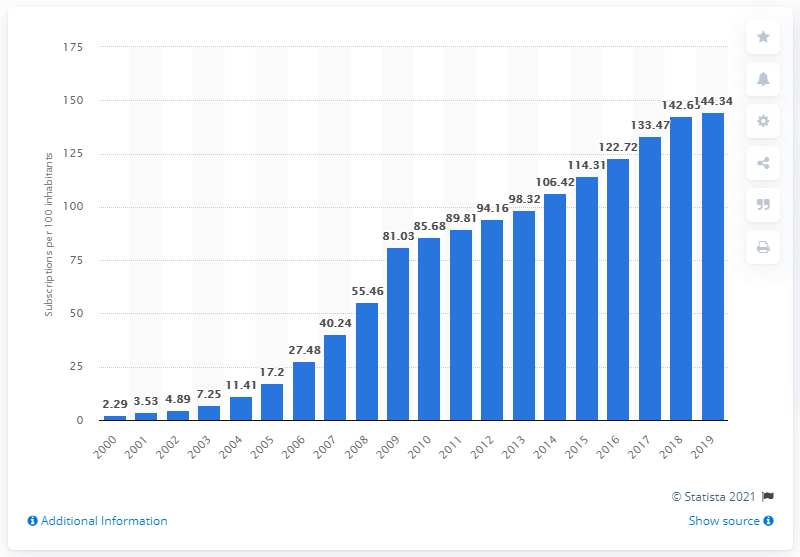Point out several critical features in this image. In Sri Lanka, the number of mobile subscriptions per 100 people registered a steady increase from 2000 to 2019, reaching 144.34 in the last year of the period. 